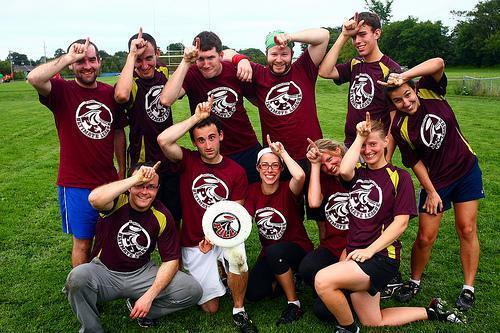How many people are in the picture?
Give a very brief answer. 11. 